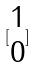Convert formula to latex. <formula><loc_0><loc_0><loc_500><loc_500>[ \begin{matrix} 1 \\ 0 \end{matrix} ]</formula> 